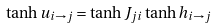Convert formula to latex. <formula><loc_0><loc_0><loc_500><loc_500>\tanh u _ { i \rightarrow j } = \tanh J _ { j i } \tanh h _ { i \rightarrow j }</formula> 